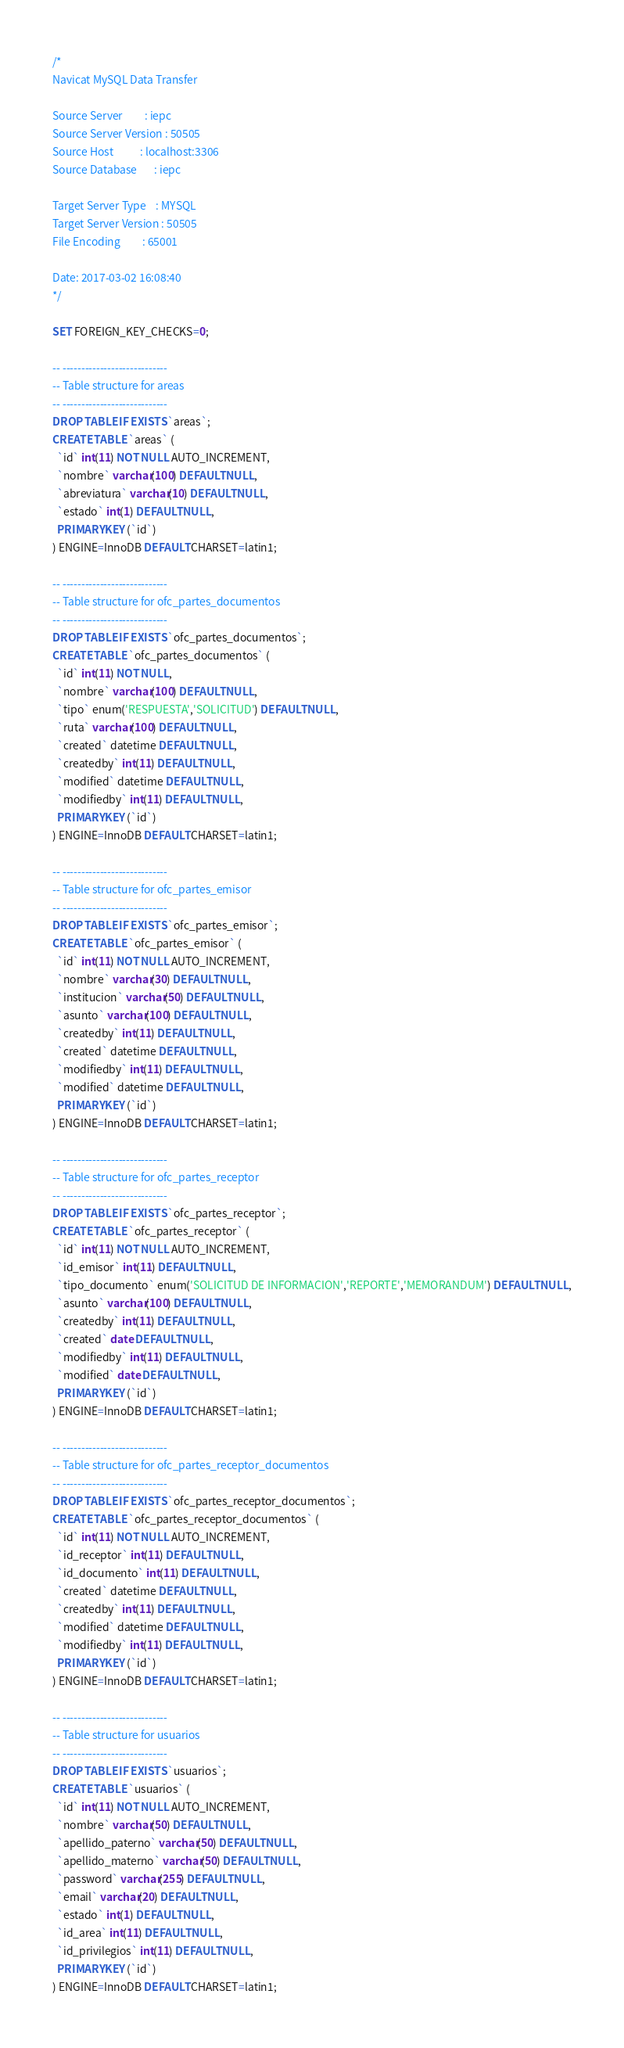<code> <loc_0><loc_0><loc_500><loc_500><_SQL_>/*
Navicat MySQL Data Transfer

Source Server         : iepc
Source Server Version : 50505
Source Host           : localhost:3306
Source Database       : iepc

Target Server Type    : MYSQL
Target Server Version : 50505
File Encoding         : 65001

Date: 2017-03-02 16:08:40
*/

SET FOREIGN_KEY_CHECKS=0;

-- ----------------------------
-- Table structure for areas
-- ----------------------------
DROP TABLE IF EXISTS `areas`;
CREATE TABLE `areas` (
  `id` int(11) NOT NULL AUTO_INCREMENT,
  `nombre` varchar(100) DEFAULT NULL,
  `abreviatura` varchar(10) DEFAULT NULL,
  `estado` int(1) DEFAULT NULL,
  PRIMARY KEY (`id`)
) ENGINE=InnoDB DEFAULT CHARSET=latin1;

-- ----------------------------
-- Table structure for ofc_partes_documentos
-- ----------------------------
DROP TABLE IF EXISTS `ofc_partes_documentos`;
CREATE TABLE `ofc_partes_documentos` (
  `id` int(11) NOT NULL,
  `nombre` varchar(100) DEFAULT NULL,
  `tipo` enum('RESPUESTA','SOLICITUD') DEFAULT NULL,
  `ruta` varchar(100) DEFAULT NULL,
  `created` datetime DEFAULT NULL,
  `createdby` int(11) DEFAULT NULL,
  `modified` datetime DEFAULT NULL,
  `modifiedby` int(11) DEFAULT NULL,
  PRIMARY KEY (`id`)
) ENGINE=InnoDB DEFAULT CHARSET=latin1;

-- ----------------------------
-- Table structure for ofc_partes_emisor
-- ----------------------------
DROP TABLE IF EXISTS `ofc_partes_emisor`;
CREATE TABLE `ofc_partes_emisor` (
  `id` int(11) NOT NULL AUTO_INCREMENT,
  `nombre` varchar(30) DEFAULT NULL,
  `institucion` varchar(50) DEFAULT NULL,
  `asunto` varchar(100) DEFAULT NULL,
  `createdby` int(11) DEFAULT NULL,
  `created` datetime DEFAULT NULL,
  `modifiedby` int(11) DEFAULT NULL,
  `modified` datetime DEFAULT NULL,
  PRIMARY KEY (`id`)
) ENGINE=InnoDB DEFAULT CHARSET=latin1;

-- ----------------------------
-- Table structure for ofc_partes_receptor
-- ----------------------------
DROP TABLE IF EXISTS `ofc_partes_receptor`;
CREATE TABLE `ofc_partes_receptor` (
  `id` int(11) NOT NULL AUTO_INCREMENT,
  `id_emisor` int(11) DEFAULT NULL,
  `tipo_documento` enum('SOLICITUD DE INFORMACION','REPORTE','MEMORANDUM') DEFAULT NULL,
  `asunto` varchar(100) DEFAULT NULL,
  `createdby` int(11) DEFAULT NULL,
  `created` date DEFAULT NULL,
  `modifiedby` int(11) DEFAULT NULL,
  `modified` date DEFAULT NULL,
  PRIMARY KEY (`id`)
) ENGINE=InnoDB DEFAULT CHARSET=latin1;

-- ----------------------------
-- Table structure for ofc_partes_receptor_documentos
-- ----------------------------
DROP TABLE IF EXISTS `ofc_partes_receptor_documentos`;
CREATE TABLE `ofc_partes_receptor_documentos` (
  `id` int(11) NOT NULL AUTO_INCREMENT,
  `id_receptor` int(11) DEFAULT NULL,
  `id_documento` int(11) DEFAULT NULL,
  `created` datetime DEFAULT NULL,
  `createdby` int(11) DEFAULT NULL,
  `modified` datetime DEFAULT NULL,
  `modifiedby` int(11) DEFAULT NULL,
  PRIMARY KEY (`id`)
) ENGINE=InnoDB DEFAULT CHARSET=latin1;

-- ----------------------------
-- Table structure for usuarios
-- ----------------------------
DROP TABLE IF EXISTS `usuarios`;
CREATE TABLE `usuarios` (
  `id` int(11) NOT NULL AUTO_INCREMENT,
  `nombre` varchar(50) DEFAULT NULL,
  `apellido_paterno` varchar(50) DEFAULT NULL,
  `apellido_materno` varchar(50) DEFAULT NULL,
  `password` varchar(255) DEFAULT NULL,
  `email` varchar(20) DEFAULT NULL,
  `estado` int(1) DEFAULT NULL,
  `id_area` int(11) DEFAULT NULL,
  `id_privilegios` int(11) DEFAULT NULL,
  PRIMARY KEY (`id`)
) ENGINE=InnoDB DEFAULT CHARSET=latin1;
</code> 